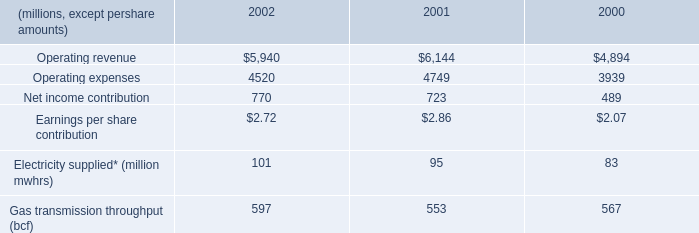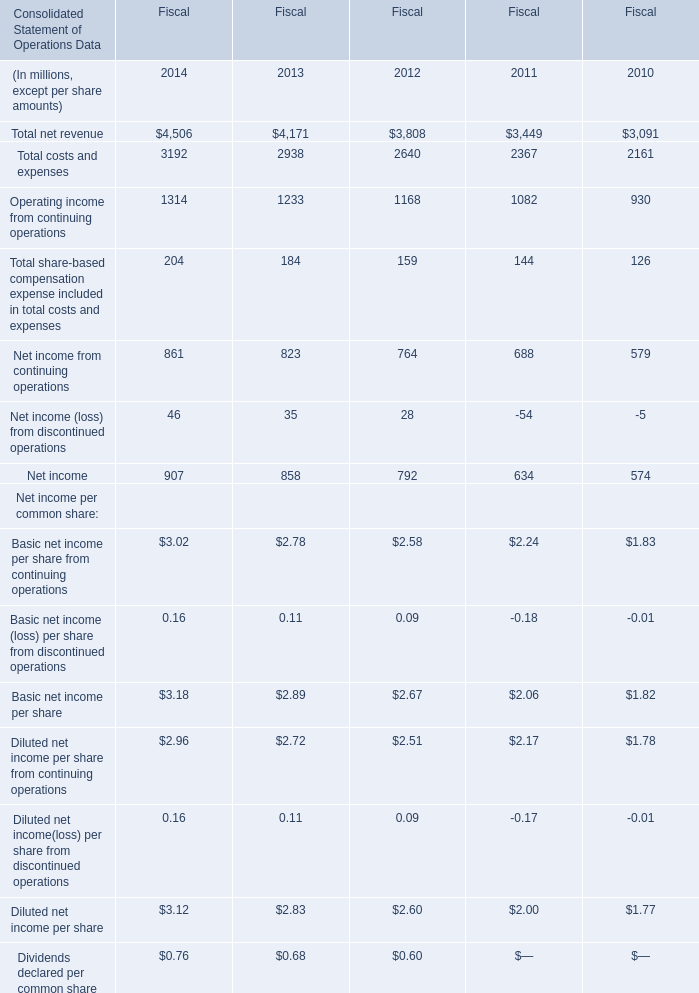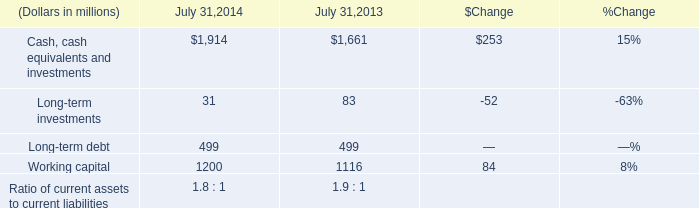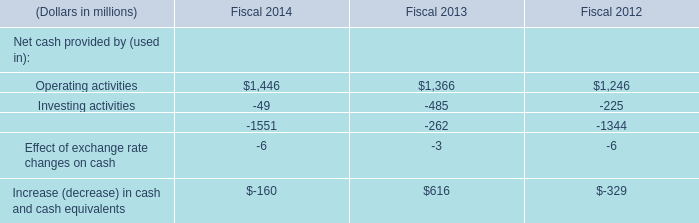what is the growth rate in operating revenue from 2000 to 2001? 
Computations: ((6144 - 4894) / 4894)
Answer: 0.25541. 